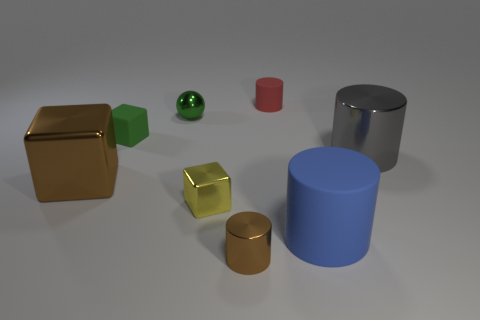Add 1 tiny metal cylinders. How many objects exist? 9 Subtract all cubes. How many objects are left? 5 Subtract all small cylinders. Subtract all gray things. How many objects are left? 5 Add 1 small metallic cubes. How many small metallic cubes are left? 2 Add 5 tiny shiny cylinders. How many tiny shiny cylinders exist? 6 Subtract 1 green balls. How many objects are left? 7 